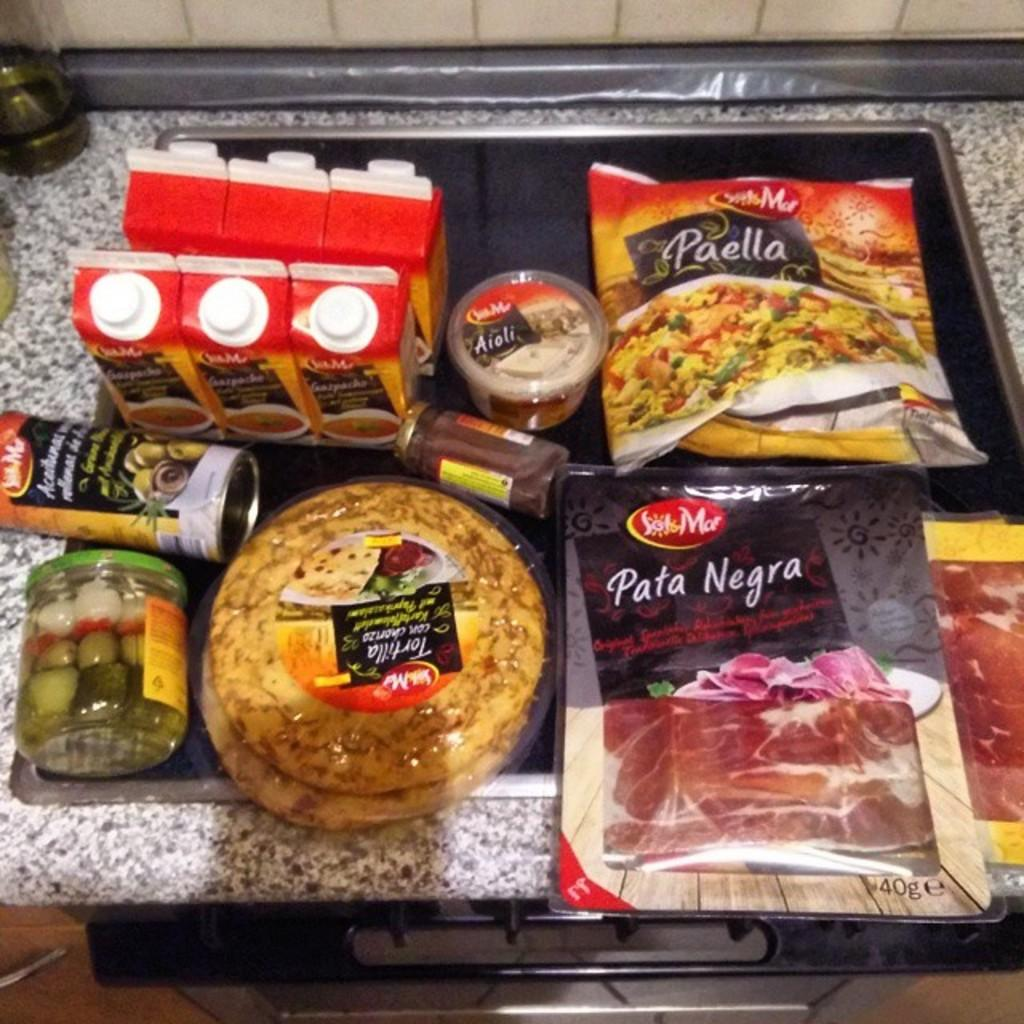What type of container holds the food items in the image? The food items are in a plastic packet. What type of beverage containers are visible in the image? There are juice bottles in the image. What type of condiment containers are visible in the image? There are sauce bottles in the image. What level of credit is required to purchase the food items in the image? There is no information about credit or purchasing in the image, as it only shows food items, juice bottles, and sauce bottles. 